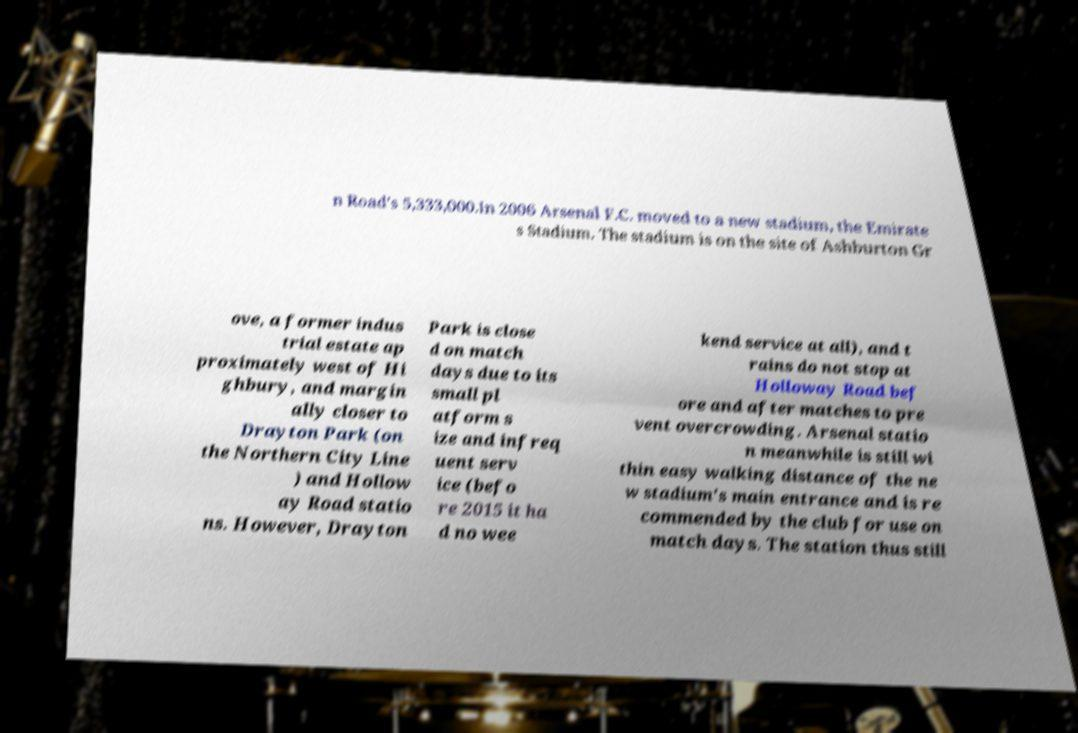Can you accurately transcribe the text from the provided image for me? n Road's 5,333,000.In 2006 Arsenal F.C. moved to a new stadium, the Emirate s Stadium. The stadium is on the site of Ashburton Gr ove, a former indus trial estate ap proximately west of Hi ghbury, and margin ally closer to Drayton Park (on the Northern City Line ) and Hollow ay Road statio ns. However, Drayton Park is close d on match days due to its small pl atform s ize and infreq uent serv ice (befo re 2015 it ha d no wee kend service at all), and t rains do not stop at Holloway Road bef ore and after matches to pre vent overcrowding. Arsenal statio n meanwhile is still wi thin easy walking distance of the ne w stadium's main entrance and is re commended by the club for use on match days. The station thus still 